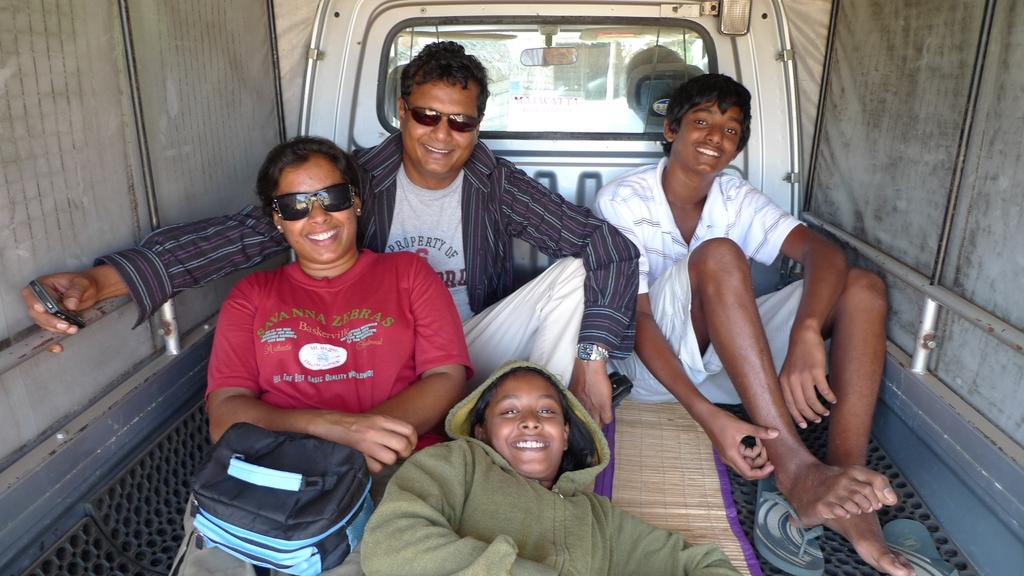What is the setting of the image? The image is taken inside a vehicle. What are the people in the vehicle doing? There are people sitting and lying in the vehicle. Can you describe the woman in the vehicle? The woman in the vehicle is wearing black color specs. What type of balloon can be seen floating in the vehicle? There is no balloon present in the image. What sound can be heard coming from the woman in the vehicle? The image is a still photograph, so no sound can be heard. 